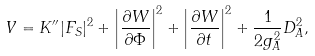Convert formula to latex. <formula><loc_0><loc_0><loc_500><loc_500>V = K ^ { \prime \prime } | F _ { S } | ^ { 2 } + \left | \frac { \partial W } { \partial \Phi } \right | ^ { 2 } + \left | \frac { \partial W } { \partial t } \right | ^ { 2 } + \frac { 1 } { 2 g _ { A } ^ { 2 } } D _ { A } ^ { 2 } ,</formula> 